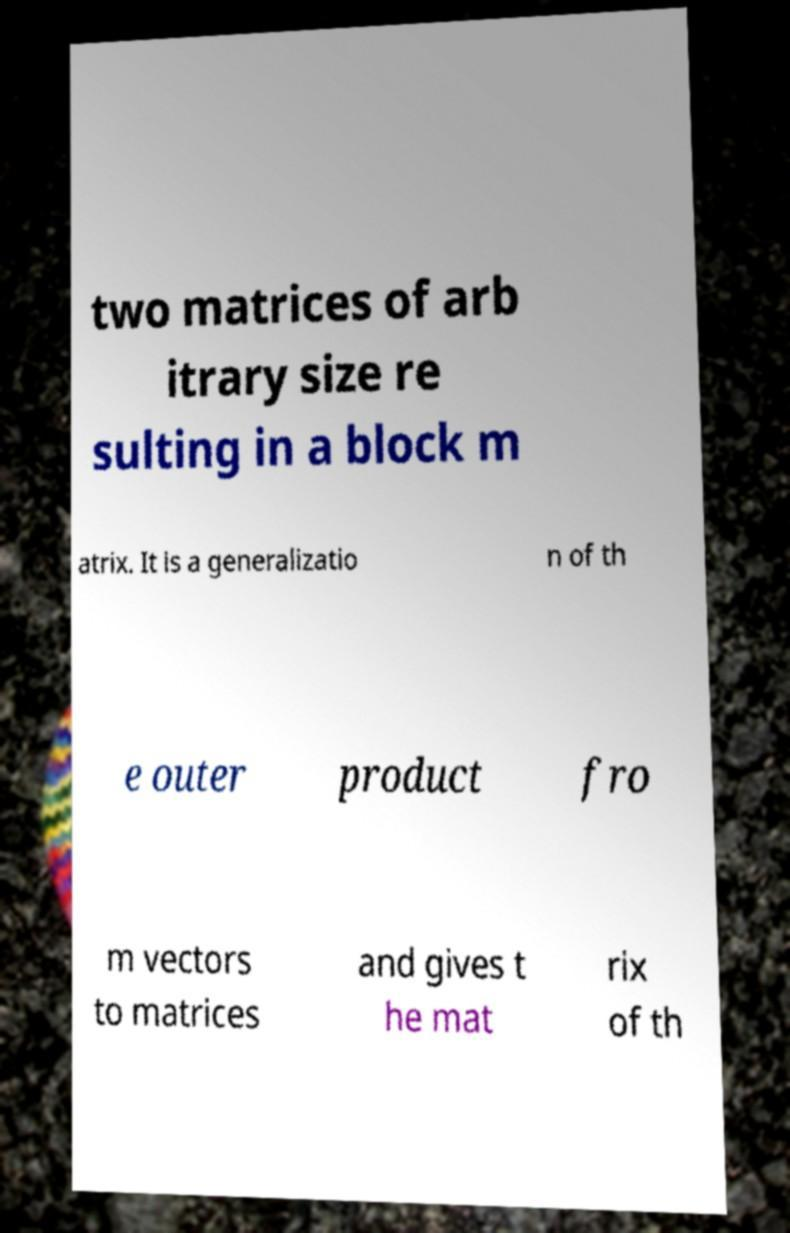What messages or text are displayed in this image? I need them in a readable, typed format. two matrices of arb itrary size re sulting in a block m atrix. It is a generalizatio n of th e outer product fro m vectors to matrices and gives t he mat rix of th 